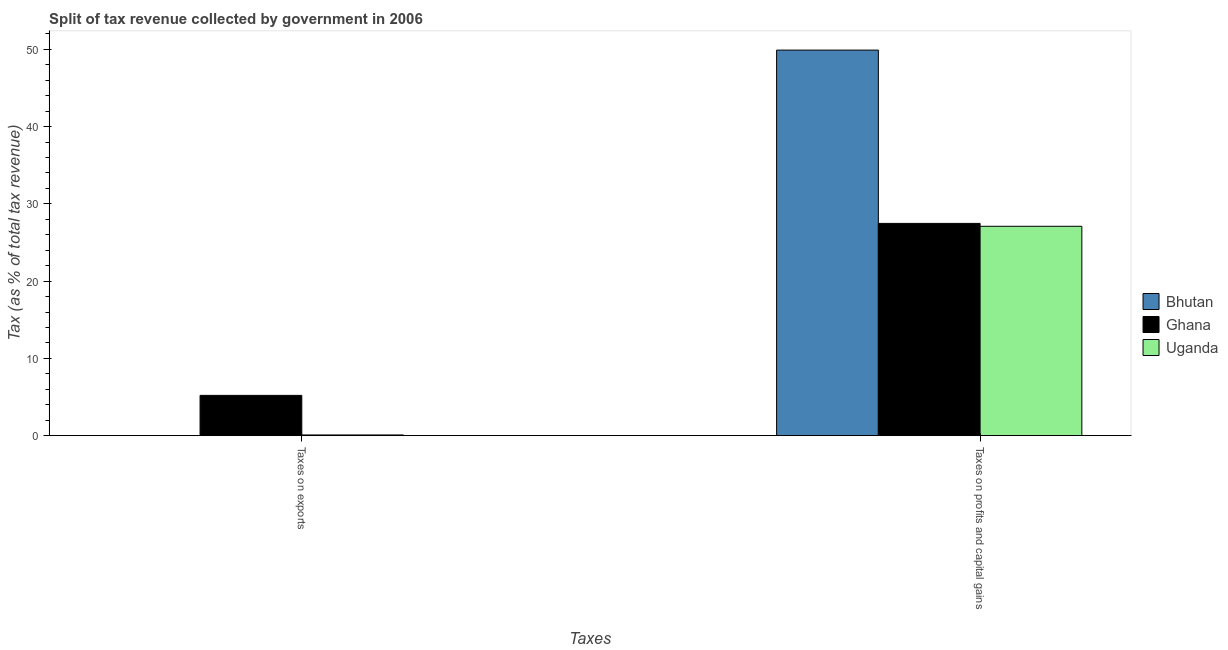How many groups of bars are there?
Give a very brief answer. 2. Are the number of bars per tick equal to the number of legend labels?
Your answer should be very brief. Yes. Are the number of bars on each tick of the X-axis equal?
Keep it short and to the point. Yes. How many bars are there on the 2nd tick from the left?
Offer a very short reply. 3. How many bars are there on the 2nd tick from the right?
Your response must be concise. 3. What is the label of the 2nd group of bars from the left?
Give a very brief answer. Taxes on profits and capital gains. What is the percentage of revenue obtained from taxes on profits and capital gains in Uganda?
Provide a succinct answer. 27.1. Across all countries, what is the maximum percentage of revenue obtained from taxes on profits and capital gains?
Give a very brief answer. 49.91. Across all countries, what is the minimum percentage of revenue obtained from taxes on exports?
Give a very brief answer. 0.01. In which country was the percentage of revenue obtained from taxes on exports minimum?
Your answer should be very brief. Bhutan. What is the total percentage of revenue obtained from taxes on exports in the graph?
Offer a terse response. 5.31. What is the difference between the percentage of revenue obtained from taxes on exports in Uganda and that in Bhutan?
Offer a terse response. 0.08. What is the difference between the percentage of revenue obtained from taxes on exports in Bhutan and the percentage of revenue obtained from taxes on profits and capital gains in Ghana?
Your response must be concise. -27.47. What is the average percentage of revenue obtained from taxes on profits and capital gains per country?
Provide a short and direct response. 34.83. What is the difference between the percentage of revenue obtained from taxes on exports and percentage of revenue obtained from taxes on profits and capital gains in Bhutan?
Make the answer very short. -49.9. What is the ratio of the percentage of revenue obtained from taxes on profits and capital gains in Uganda to that in Ghana?
Offer a terse response. 0.99. Is the percentage of revenue obtained from taxes on profits and capital gains in Ghana less than that in Bhutan?
Your response must be concise. Yes. What does the 3rd bar from the left in Taxes on profits and capital gains represents?
Offer a terse response. Uganda. What does the 2nd bar from the right in Taxes on profits and capital gains represents?
Provide a succinct answer. Ghana. Are all the bars in the graph horizontal?
Offer a very short reply. No. How many countries are there in the graph?
Keep it short and to the point. 3. Does the graph contain any zero values?
Your response must be concise. No. Where does the legend appear in the graph?
Keep it short and to the point. Center right. How are the legend labels stacked?
Your answer should be very brief. Vertical. What is the title of the graph?
Your answer should be very brief. Split of tax revenue collected by government in 2006. Does "Slovak Republic" appear as one of the legend labels in the graph?
Provide a succinct answer. No. What is the label or title of the X-axis?
Give a very brief answer. Taxes. What is the label or title of the Y-axis?
Your answer should be compact. Tax (as % of total tax revenue). What is the Tax (as % of total tax revenue) of Bhutan in Taxes on exports?
Your answer should be very brief. 0.01. What is the Tax (as % of total tax revenue) in Ghana in Taxes on exports?
Your response must be concise. 5.21. What is the Tax (as % of total tax revenue) in Uganda in Taxes on exports?
Offer a terse response. 0.09. What is the Tax (as % of total tax revenue) of Bhutan in Taxes on profits and capital gains?
Provide a short and direct response. 49.91. What is the Tax (as % of total tax revenue) of Ghana in Taxes on profits and capital gains?
Provide a short and direct response. 27.47. What is the Tax (as % of total tax revenue) of Uganda in Taxes on profits and capital gains?
Offer a terse response. 27.1. Across all Taxes, what is the maximum Tax (as % of total tax revenue) of Bhutan?
Offer a very short reply. 49.91. Across all Taxes, what is the maximum Tax (as % of total tax revenue) in Ghana?
Make the answer very short. 27.47. Across all Taxes, what is the maximum Tax (as % of total tax revenue) in Uganda?
Offer a terse response. 27.1. Across all Taxes, what is the minimum Tax (as % of total tax revenue) of Bhutan?
Offer a very short reply. 0.01. Across all Taxes, what is the minimum Tax (as % of total tax revenue) in Ghana?
Your answer should be compact. 5.21. Across all Taxes, what is the minimum Tax (as % of total tax revenue) of Uganda?
Make the answer very short. 0.09. What is the total Tax (as % of total tax revenue) of Bhutan in the graph?
Make the answer very short. 49.92. What is the total Tax (as % of total tax revenue) of Ghana in the graph?
Keep it short and to the point. 32.69. What is the total Tax (as % of total tax revenue) in Uganda in the graph?
Offer a terse response. 27.19. What is the difference between the Tax (as % of total tax revenue) of Bhutan in Taxes on exports and that in Taxes on profits and capital gains?
Give a very brief answer. -49.9. What is the difference between the Tax (as % of total tax revenue) of Ghana in Taxes on exports and that in Taxes on profits and capital gains?
Ensure brevity in your answer.  -22.26. What is the difference between the Tax (as % of total tax revenue) in Uganda in Taxes on exports and that in Taxes on profits and capital gains?
Offer a very short reply. -27.01. What is the difference between the Tax (as % of total tax revenue) of Bhutan in Taxes on exports and the Tax (as % of total tax revenue) of Ghana in Taxes on profits and capital gains?
Your response must be concise. -27.47. What is the difference between the Tax (as % of total tax revenue) in Bhutan in Taxes on exports and the Tax (as % of total tax revenue) in Uganda in Taxes on profits and capital gains?
Offer a very short reply. -27.09. What is the difference between the Tax (as % of total tax revenue) of Ghana in Taxes on exports and the Tax (as % of total tax revenue) of Uganda in Taxes on profits and capital gains?
Give a very brief answer. -21.89. What is the average Tax (as % of total tax revenue) of Bhutan per Taxes?
Give a very brief answer. 24.96. What is the average Tax (as % of total tax revenue) of Ghana per Taxes?
Provide a short and direct response. 16.34. What is the average Tax (as % of total tax revenue) of Uganda per Taxes?
Provide a succinct answer. 13.6. What is the difference between the Tax (as % of total tax revenue) of Bhutan and Tax (as % of total tax revenue) of Ghana in Taxes on exports?
Keep it short and to the point. -5.2. What is the difference between the Tax (as % of total tax revenue) in Bhutan and Tax (as % of total tax revenue) in Uganda in Taxes on exports?
Give a very brief answer. -0.08. What is the difference between the Tax (as % of total tax revenue) of Ghana and Tax (as % of total tax revenue) of Uganda in Taxes on exports?
Provide a short and direct response. 5.12. What is the difference between the Tax (as % of total tax revenue) in Bhutan and Tax (as % of total tax revenue) in Ghana in Taxes on profits and capital gains?
Make the answer very short. 22.43. What is the difference between the Tax (as % of total tax revenue) in Bhutan and Tax (as % of total tax revenue) in Uganda in Taxes on profits and capital gains?
Keep it short and to the point. 22.81. What is the difference between the Tax (as % of total tax revenue) in Ghana and Tax (as % of total tax revenue) in Uganda in Taxes on profits and capital gains?
Your response must be concise. 0.37. What is the ratio of the Tax (as % of total tax revenue) of Ghana in Taxes on exports to that in Taxes on profits and capital gains?
Provide a succinct answer. 0.19. What is the ratio of the Tax (as % of total tax revenue) in Uganda in Taxes on exports to that in Taxes on profits and capital gains?
Your response must be concise. 0. What is the difference between the highest and the second highest Tax (as % of total tax revenue) of Bhutan?
Keep it short and to the point. 49.9. What is the difference between the highest and the second highest Tax (as % of total tax revenue) of Ghana?
Provide a succinct answer. 22.26. What is the difference between the highest and the second highest Tax (as % of total tax revenue) of Uganda?
Keep it short and to the point. 27.01. What is the difference between the highest and the lowest Tax (as % of total tax revenue) of Bhutan?
Provide a succinct answer. 49.9. What is the difference between the highest and the lowest Tax (as % of total tax revenue) of Ghana?
Offer a terse response. 22.26. What is the difference between the highest and the lowest Tax (as % of total tax revenue) of Uganda?
Offer a very short reply. 27.01. 